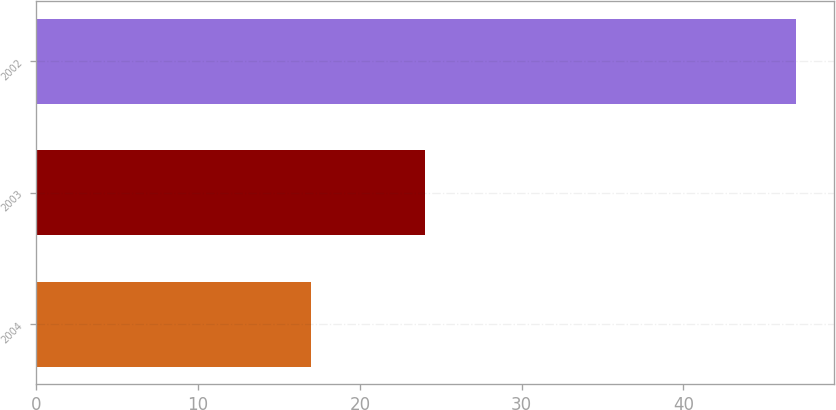Convert chart to OTSL. <chart><loc_0><loc_0><loc_500><loc_500><bar_chart><fcel>2004<fcel>2003<fcel>2002<nl><fcel>17<fcel>24<fcel>47<nl></chart> 